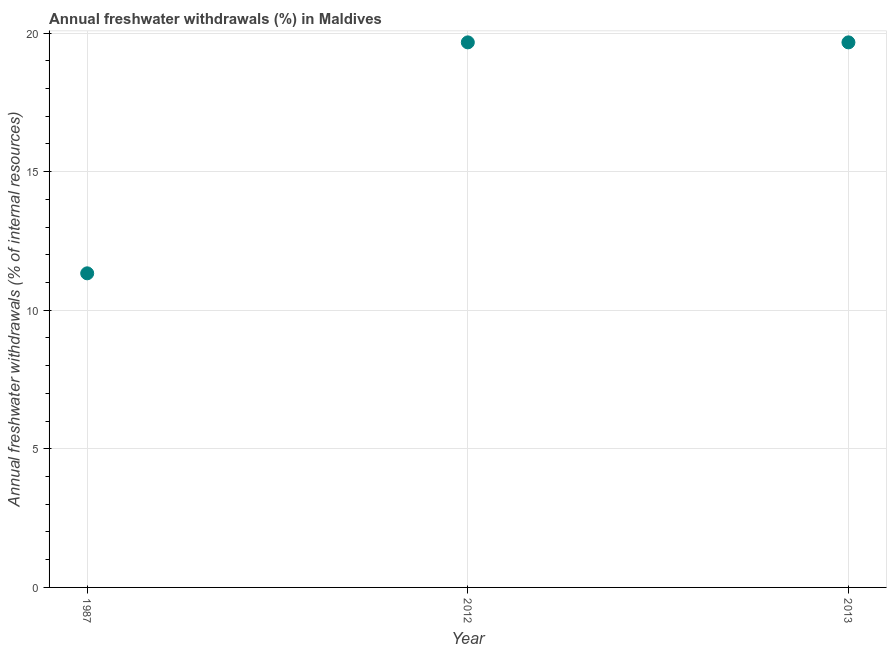What is the annual freshwater withdrawals in 1987?
Give a very brief answer. 11.33. Across all years, what is the maximum annual freshwater withdrawals?
Ensure brevity in your answer.  19.67. Across all years, what is the minimum annual freshwater withdrawals?
Make the answer very short. 11.33. In which year was the annual freshwater withdrawals minimum?
Make the answer very short. 1987. What is the sum of the annual freshwater withdrawals?
Your answer should be compact. 50.67. What is the difference between the annual freshwater withdrawals in 2012 and 2013?
Keep it short and to the point. 0. What is the average annual freshwater withdrawals per year?
Offer a very short reply. 16.89. What is the median annual freshwater withdrawals?
Your response must be concise. 19.67. Do a majority of the years between 1987 and 2013 (inclusive) have annual freshwater withdrawals greater than 9 %?
Give a very brief answer. Yes. What is the ratio of the annual freshwater withdrawals in 1987 to that in 2012?
Provide a succinct answer. 0.58. What is the difference between the highest and the second highest annual freshwater withdrawals?
Make the answer very short. 0. What is the difference between the highest and the lowest annual freshwater withdrawals?
Your answer should be very brief. 8.33. In how many years, is the annual freshwater withdrawals greater than the average annual freshwater withdrawals taken over all years?
Make the answer very short. 2. How many dotlines are there?
Offer a very short reply. 1. How many years are there in the graph?
Make the answer very short. 3. Does the graph contain grids?
Offer a very short reply. Yes. What is the title of the graph?
Give a very brief answer. Annual freshwater withdrawals (%) in Maldives. What is the label or title of the X-axis?
Keep it short and to the point. Year. What is the label or title of the Y-axis?
Ensure brevity in your answer.  Annual freshwater withdrawals (% of internal resources). What is the Annual freshwater withdrawals (% of internal resources) in 1987?
Provide a succinct answer. 11.33. What is the Annual freshwater withdrawals (% of internal resources) in 2012?
Make the answer very short. 19.67. What is the Annual freshwater withdrawals (% of internal resources) in 2013?
Keep it short and to the point. 19.67. What is the difference between the Annual freshwater withdrawals (% of internal resources) in 1987 and 2012?
Provide a short and direct response. -8.33. What is the difference between the Annual freshwater withdrawals (% of internal resources) in 1987 and 2013?
Keep it short and to the point. -8.33. What is the ratio of the Annual freshwater withdrawals (% of internal resources) in 1987 to that in 2012?
Keep it short and to the point. 0.58. What is the ratio of the Annual freshwater withdrawals (% of internal resources) in 1987 to that in 2013?
Your answer should be compact. 0.58. What is the ratio of the Annual freshwater withdrawals (% of internal resources) in 2012 to that in 2013?
Provide a succinct answer. 1. 